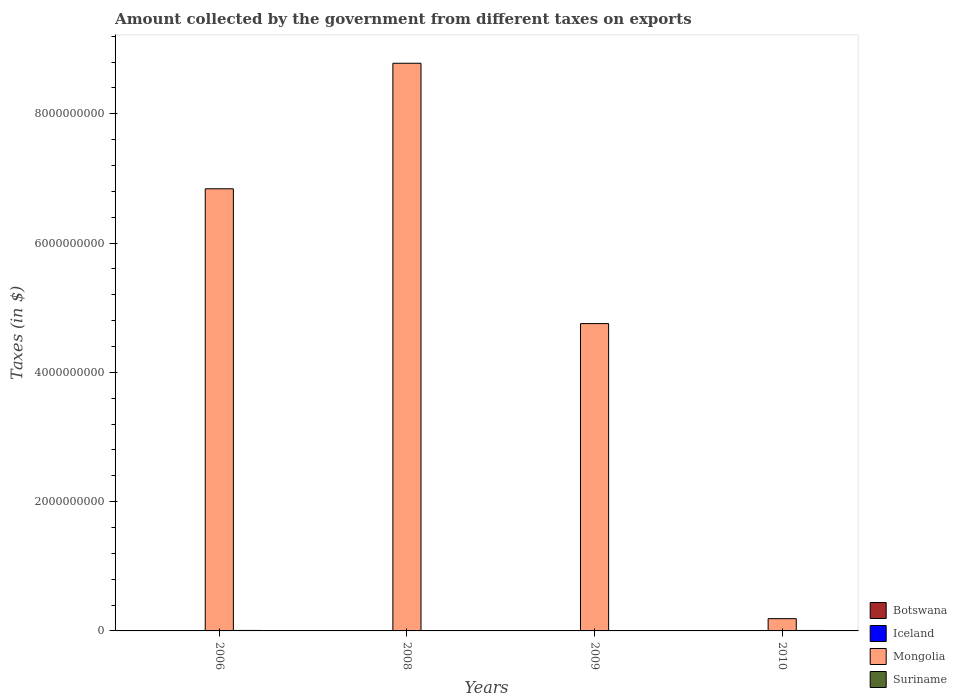How many different coloured bars are there?
Make the answer very short. 4. How many groups of bars are there?
Provide a short and direct response. 4. Are the number of bars per tick equal to the number of legend labels?
Ensure brevity in your answer.  Yes. How many bars are there on the 4th tick from the right?
Offer a terse response. 4. What is the label of the 1st group of bars from the left?
Make the answer very short. 2006. In how many cases, is the number of bars for a given year not equal to the number of legend labels?
Provide a short and direct response. 0. What is the amount collected by the government from taxes on exports in Iceland in 2008?
Provide a succinct answer. 6.26e+06. Across all years, what is the maximum amount collected by the government from taxes on exports in Botswana?
Your response must be concise. 1.69e+06. Across all years, what is the minimum amount collected by the government from taxes on exports in Suriname?
Make the answer very short. 4.27e+06. In which year was the amount collected by the government from taxes on exports in Suriname maximum?
Your response must be concise. 2006. What is the total amount collected by the government from taxes on exports in Botswana in the graph?
Your answer should be very brief. 4.41e+06. What is the difference between the amount collected by the government from taxes on exports in Mongolia in 2006 and that in 2008?
Make the answer very short. -1.94e+09. What is the difference between the amount collected by the government from taxes on exports in Botswana in 2008 and the amount collected by the government from taxes on exports in Mongolia in 2009?
Offer a very short reply. -4.75e+09. What is the average amount collected by the government from taxes on exports in Suriname per year?
Give a very brief answer. 6.07e+06. In the year 2008, what is the difference between the amount collected by the government from taxes on exports in Iceland and amount collected by the government from taxes on exports in Mongolia?
Your answer should be very brief. -8.78e+09. In how many years, is the amount collected by the government from taxes on exports in Iceland greater than 1600000000 $?
Keep it short and to the point. 0. What is the ratio of the amount collected by the government from taxes on exports in Iceland in 2008 to that in 2010?
Your response must be concise. 3.81. Is the amount collected by the government from taxes on exports in Iceland in 2006 less than that in 2008?
Offer a terse response. Yes. What is the difference between the highest and the second highest amount collected by the government from taxes on exports in Mongolia?
Ensure brevity in your answer.  1.94e+09. What is the difference between the highest and the lowest amount collected by the government from taxes on exports in Mongolia?
Keep it short and to the point. 8.59e+09. In how many years, is the amount collected by the government from taxes on exports in Suriname greater than the average amount collected by the government from taxes on exports in Suriname taken over all years?
Give a very brief answer. 2. What does the 4th bar from the right in 2009 represents?
Provide a succinct answer. Botswana. Are all the bars in the graph horizontal?
Your response must be concise. No. What is the difference between two consecutive major ticks on the Y-axis?
Keep it short and to the point. 2.00e+09. Are the values on the major ticks of Y-axis written in scientific E-notation?
Provide a short and direct response. No. Does the graph contain grids?
Your response must be concise. No. Where does the legend appear in the graph?
Your answer should be compact. Bottom right. How are the legend labels stacked?
Provide a short and direct response. Vertical. What is the title of the graph?
Give a very brief answer. Amount collected by the government from different taxes on exports. What is the label or title of the Y-axis?
Keep it short and to the point. Taxes (in $). What is the Taxes (in $) of Iceland in 2006?
Keep it short and to the point. 3.10e+06. What is the Taxes (in $) in Mongolia in 2006?
Give a very brief answer. 6.84e+09. What is the Taxes (in $) in Suriname in 2006?
Give a very brief answer. 7.49e+06. What is the Taxes (in $) in Botswana in 2008?
Offer a terse response. 1.65e+06. What is the Taxes (in $) in Iceland in 2008?
Your answer should be compact. 6.26e+06. What is the Taxes (in $) in Mongolia in 2008?
Provide a succinct answer. 8.78e+09. What is the Taxes (in $) in Suriname in 2008?
Your answer should be compact. 5.36e+06. What is the Taxes (in $) of Botswana in 2009?
Your response must be concise. 7.10e+05. What is the Taxes (in $) in Iceland in 2009?
Offer a very short reply. 5.41e+06. What is the Taxes (in $) of Mongolia in 2009?
Ensure brevity in your answer.  4.75e+09. What is the Taxes (in $) of Suriname in 2009?
Offer a very short reply. 4.27e+06. What is the Taxes (in $) in Botswana in 2010?
Keep it short and to the point. 1.69e+06. What is the Taxes (in $) in Iceland in 2010?
Keep it short and to the point. 1.64e+06. What is the Taxes (in $) in Mongolia in 2010?
Give a very brief answer. 1.90e+08. What is the Taxes (in $) of Suriname in 2010?
Your answer should be compact. 7.16e+06. Across all years, what is the maximum Taxes (in $) in Botswana?
Give a very brief answer. 1.69e+06. Across all years, what is the maximum Taxes (in $) in Iceland?
Ensure brevity in your answer.  6.26e+06. Across all years, what is the maximum Taxes (in $) in Mongolia?
Provide a succinct answer. 8.78e+09. Across all years, what is the maximum Taxes (in $) of Suriname?
Offer a very short reply. 7.49e+06. Across all years, what is the minimum Taxes (in $) of Botswana?
Offer a terse response. 3.60e+05. Across all years, what is the minimum Taxes (in $) in Iceland?
Offer a very short reply. 1.64e+06. Across all years, what is the minimum Taxes (in $) of Mongolia?
Your answer should be compact. 1.90e+08. Across all years, what is the minimum Taxes (in $) of Suriname?
Your answer should be very brief. 4.27e+06. What is the total Taxes (in $) of Botswana in the graph?
Keep it short and to the point. 4.41e+06. What is the total Taxes (in $) of Iceland in the graph?
Provide a succinct answer. 1.64e+07. What is the total Taxes (in $) in Mongolia in the graph?
Provide a succinct answer. 2.06e+1. What is the total Taxes (in $) in Suriname in the graph?
Provide a succinct answer. 2.43e+07. What is the difference between the Taxes (in $) in Botswana in 2006 and that in 2008?
Give a very brief answer. -1.29e+06. What is the difference between the Taxes (in $) of Iceland in 2006 and that in 2008?
Offer a terse response. -3.16e+06. What is the difference between the Taxes (in $) of Mongolia in 2006 and that in 2008?
Your response must be concise. -1.94e+09. What is the difference between the Taxes (in $) in Suriname in 2006 and that in 2008?
Give a very brief answer. 2.14e+06. What is the difference between the Taxes (in $) in Botswana in 2006 and that in 2009?
Provide a succinct answer. -3.50e+05. What is the difference between the Taxes (in $) of Iceland in 2006 and that in 2009?
Your response must be concise. -2.31e+06. What is the difference between the Taxes (in $) in Mongolia in 2006 and that in 2009?
Provide a succinct answer. 2.09e+09. What is the difference between the Taxes (in $) in Suriname in 2006 and that in 2009?
Offer a terse response. 3.22e+06. What is the difference between the Taxes (in $) in Botswana in 2006 and that in 2010?
Offer a very short reply. -1.33e+06. What is the difference between the Taxes (in $) of Iceland in 2006 and that in 2010?
Make the answer very short. 1.46e+06. What is the difference between the Taxes (in $) in Mongolia in 2006 and that in 2010?
Provide a succinct answer. 6.65e+09. What is the difference between the Taxes (in $) of Suriname in 2006 and that in 2010?
Offer a very short reply. 3.33e+05. What is the difference between the Taxes (in $) of Botswana in 2008 and that in 2009?
Keep it short and to the point. 9.40e+05. What is the difference between the Taxes (in $) in Iceland in 2008 and that in 2009?
Provide a short and direct response. 8.44e+05. What is the difference between the Taxes (in $) in Mongolia in 2008 and that in 2009?
Provide a succinct answer. 4.03e+09. What is the difference between the Taxes (in $) of Suriname in 2008 and that in 2009?
Your response must be concise. 1.08e+06. What is the difference between the Taxes (in $) in Iceland in 2008 and that in 2010?
Give a very brief answer. 4.61e+06. What is the difference between the Taxes (in $) in Mongolia in 2008 and that in 2010?
Ensure brevity in your answer.  8.59e+09. What is the difference between the Taxes (in $) in Suriname in 2008 and that in 2010?
Give a very brief answer. -1.81e+06. What is the difference between the Taxes (in $) in Botswana in 2009 and that in 2010?
Ensure brevity in your answer.  -9.80e+05. What is the difference between the Taxes (in $) of Iceland in 2009 and that in 2010?
Make the answer very short. 3.77e+06. What is the difference between the Taxes (in $) in Mongolia in 2009 and that in 2010?
Your answer should be compact. 4.57e+09. What is the difference between the Taxes (in $) in Suriname in 2009 and that in 2010?
Your answer should be very brief. -2.89e+06. What is the difference between the Taxes (in $) in Botswana in 2006 and the Taxes (in $) in Iceland in 2008?
Keep it short and to the point. -5.90e+06. What is the difference between the Taxes (in $) in Botswana in 2006 and the Taxes (in $) in Mongolia in 2008?
Keep it short and to the point. -8.78e+09. What is the difference between the Taxes (in $) of Botswana in 2006 and the Taxes (in $) of Suriname in 2008?
Offer a terse response. -5.00e+06. What is the difference between the Taxes (in $) in Iceland in 2006 and the Taxes (in $) in Mongolia in 2008?
Provide a succinct answer. -8.78e+09. What is the difference between the Taxes (in $) in Iceland in 2006 and the Taxes (in $) in Suriname in 2008?
Keep it short and to the point. -2.26e+06. What is the difference between the Taxes (in $) in Mongolia in 2006 and the Taxes (in $) in Suriname in 2008?
Give a very brief answer. 6.83e+09. What is the difference between the Taxes (in $) of Botswana in 2006 and the Taxes (in $) of Iceland in 2009?
Ensure brevity in your answer.  -5.05e+06. What is the difference between the Taxes (in $) in Botswana in 2006 and the Taxes (in $) in Mongolia in 2009?
Offer a very short reply. -4.75e+09. What is the difference between the Taxes (in $) in Botswana in 2006 and the Taxes (in $) in Suriname in 2009?
Your answer should be compact. -3.91e+06. What is the difference between the Taxes (in $) in Iceland in 2006 and the Taxes (in $) in Mongolia in 2009?
Give a very brief answer. -4.75e+09. What is the difference between the Taxes (in $) of Iceland in 2006 and the Taxes (in $) of Suriname in 2009?
Provide a succinct answer. -1.17e+06. What is the difference between the Taxes (in $) of Mongolia in 2006 and the Taxes (in $) of Suriname in 2009?
Provide a succinct answer. 6.84e+09. What is the difference between the Taxes (in $) in Botswana in 2006 and the Taxes (in $) in Iceland in 2010?
Give a very brief answer. -1.28e+06. What is the difference between the Taxes (in $) in Botswana in 2006 and the Taxes (in $) in Mongolia in 2010?
Offer a terse response. -1.89e+08. What is the difference between the Taxes (in $) in Botswana in 2006 and the Taxes (in $) in Suriname in 2010?
Make the answer very short. -6.80e+06. What is the difference between the Taxes (in $) in Iceland in 2006 and the Taxes (in $) in Mongolia in 2010?
Ensure brevity in your answer.  -1.87e+08. What is the difference between the Taxes (in $) in Iceland in 2006 and the Taxes (in $) in Suriname in 2010?
Keep it short and to the point. -4.06e+06. What is the difference between the Taxes (in $) of Mongolia in 2006 and the Taxes (in $) of Suriname in 2010?
Provide a succinct answer. 6.83e+09. What is the difference between the Taxes (in $) of Botswana in 2008 and the Taxes (in $) of Iceland in 2009?
Make the answer very short. -3.76e+06. What is the difference between the Taxes (in $) of Botswana in 2008 and the Taxes (in $) of Mongolia in 2009?
Ensure brevity in your answer.  -4.75e+09. What is the difference between the Taxes (in $) of Botswana in 2008 and the Taxes (in $) of Suriname in 2009?
Make the answer very short. -2.62e+06. What is the difference between the Taxes (in $) in Iceland in 2008 and the Taxes (in $) in Mongolia in 2009?
Offer a very short reply. -4.75e+09. What is the difference between the Taxes (in $) in Iceland in 2008 and the Taxes (in $) in Suriname in 2009?
Offer a terse response. 1.98e+06. What is the difference between the Taxes (in $) in Mongolia in 2008 and the Taxes (in $) in Suriname in 2009?
Your response must be concise. 8.78e+09. What is the difference between the Taxes (in $) of Botswana in 2008 and the Taxes (in $) of Iceland in 2010?
Your answer should be very brief. 8550. What is the difference between the Taxes (in $) in Botswana in 2008 and the Taxes (in $) in Mongolia in 2010?
Offer a very short reply. -1.88e+08. What is the difference between the Taxes (in $) of Botswana in 2008 and the Taxes (in $) of Suriname in 2010?
Provide a short and direct response. -5.51e+06. What is the difference between the Taxes (in $) of Iceland in 2008 and the Taxes (in $) of Mongolia in 2010?
Offer a terse response. -1.84e+08. What is the difference between the Taxes (in $) in Iceland in 2008 and the Taxes (in $) in Suriname in 2010?
Your answer should be very brief. -9.07e+05. What is the difference between the Taxes (in $) in Mongolia in 2008 and the Taxes (in $) in Suriname in 2010?
Your answer should be very brief. 8.78e+09. What is the difference between the Taxes (in $) in Botswana in 2009 and the Taxes (in $) in Iceland in 2010?
Ensure brevity in your answer.  -9.31e+05. What is the difference between the Taxes (in $) in Botswana in 2009 and the Taxes (in $) in Mongolia in 2010?
Provide a short and direct response. -1.89e+08. What is the difference between the Taxes (in $) of Botswana in 2009 and the Taxes (in $) of Suriname in 2010?
Your answer should be very brief. -6.45e+06. What is the difference between the Taxes (in $) in Iceland in 2009 and the Taxes (in $) in Mongolia in 2010?
Give a very brief answer. -1.84e+08. What is the difference between the Taxes (in $) in Iceland in 2009 and the Taxes (in $) in Suriname in 2010?
Your response must be concise. -1.75e+06. What is the difference between the Taxes (in $) of Mongolia in 2009 and the Taxes (in $) of Suriname in 2010?
Your response must be concise. 4.75e+09. What is the average Taxes (in $) of Botswana per year?
Offer a terse response. 1.10e+06. What is the average Taxes (in $) of Iceland per year?
Your answer should be very brief. 4.10e+06. What is the average Taxes (in $) of Mongolia per year?
Ensure brevity in your answer.  5.14e+09. What is the average Taxes (in $) of Suriname per year?
Provide a succinct answer. 6.07e+06. In the year 2006, what is the difference between the Taxes (in $) of Botswana and Taxes (in $) of Iceland?
Offer a terse response. -2.74e+06. In the year 2006, what is the difference between the Taxes (in $) of Botswana and Taxes (in $) of Mongolia?
Offer a very short reply. -6.84e+09. In the year 2006, what is the difference between the Taxes (in $) of Botswana and Taxes (in $) of Suriname?
Your answer should be compact. -7.13e+06. In the year 2006, what is the difference between the Taxes (in $) of Iceland and Taxes (in $) of Mongolia?
Your response must be concise. -6.84e+09. In the year 2006, what is the difference between the Taxes (in $) of Iceland and Taxes (in $) of Suriname?
Your response must be concise. -4.39e+06. In the year 2006, what is the difference between the Taxes (in $) in Mongolia and Taxes (in $) in Suriname?
Provide a succinct answer. 6.83e+09. In the year 2008, what is the difference between the Taxes (in $) of Botswana and Taxes (in $) of Iceland?
Your answer should be compact. -4.61e+06. In the year 2008, what is the difference between the Taxes (in $) in Botswana and Taxes (in $) in Mongolia?
Give a very brief answer. -8.78e+09. In the year 2008, what is the difference between the Taxes (in $) in Botswana and Taxes (in $) in Suriname?
Offer a terse response. -3.71e+06. In the year 2008, what is the difference between the Taxes (in $) of Iceland and Taxes (in $) of Mongolia?
Your response must be concise. -8.78e+09. In the year 2008, what is the difference between the Taxes (in $) in Iceland and Taxes (in $) in Suriname?
Give a very brief answer. 9.00e+05. In the year 2008, what is the difference between the Taxes (in $) of Mongolia and Taxes (in $) of Suriname?
Give a very brief answer. 8.78e+09. In the year 2009, what is the difference between the Taxes (in $) of Botswana and Taxes (in $) of Iceland?
Offer a very short reply. -4.70e+06. In the year 2009, what is the difference between the Taxes (in $) in Botswana and Taxes (in $) in Mongolia?
Your answer should be compact. -4.75e+09. In the year 2009, what is the difference between the Taxes (in $) of Botswana and Taxes (in $) of Suriname?
Your answer should be very brief. -3.56e+06. In the year 2009, what is the difference between the Taxes (in $) in Iceland and Taxes (in $) in Mongolia?
Provide a short and direct response. -4.75e+09. In the year 2009, what is the difference between the Taxes (in $) of Iceland and Taxes (in $) of Suriname?
Provide a short and direct response. 1.14e+06. In the year 2009, what is the difference between the Taxes (in $) of Mongolia and Taxes (in $) of Suriname?
Ensure brevity in your answer.  4.75e+09. In the year 2010, what is the difference between the Taxes (in $) of Botswana and Taxes (in $) of Iceland?
Provide a succinct answer. 4.86e+04. In the year 2010, what is the difference between the Taxes (in $) of Botswana and Taxes (in $) of Mongolia?
Keep it short and to the point. -1.88e+08. In the year 2010, what is the difference between the Taxes (in $) in Botswana and Taxes (in $) in Suriname?
Provide a short and direct response. -5.47e+06. In the year 2010, what is the difference between the Taxes (in $) of Iceland and Taxes (in $) of Mongolia?
Give a very brief answer. -1.88e+08. In the year 2010, what is the difference between the Taxes (in $) of Iceland and Taxes (in $) of Suriname?
Make the answer very short. -5.52e+06. In the year 2010, what is the difference between the Taxes (in $) in Mongolia and Taxes (in $) in Suriname?
Your answer should be very brief. 1.83e+08. What is the ratio of the Taxes (in $) in Botswana in 2006 to that in 2008?
Your answer should be compact. 0.22. What is the ratio of the Taxes (in $) in Iceland in 2006 to that in 2008?
Provide a short and direct response. 0.5. What is the ratio of the Taxes (in $) of Mongolia in 2006 to that in 2008?
Your answer should be very brief. 0.78. What is the ratio of the Taxes (in $) in Suriname in 2006 to that in 2008?
Your answer should be very brief. 1.4. What is the ratio of the Taxes (in $) in Botswana in 2006 to that in 2009?
Your answer should be very brief. 0.51. What is the ratio of the Taxes (in $) in Iceland in 2006 to that in 2009?
Provide a succinct answer. 0.57. What is the ratio of the Taxes (in $) in Mongolia in 2006 to that in 2009?
Keep it short and to the point. 1.44. What is the ratio of the Taxes (in $) of Suriname in 2006 to that in 2009?
Provide a short and direct response. 1.75. What is the ratio of the Taxes (in $) of Botswana in 2006 to that in 2010?
Ensure brevity in your answer.  0.21. What is the ratio of the Taxes (in $) in Iceland in 2006 to that in 2010?
Give a very brief answer. 1.89. What is the ratio of the Taxes (in $) of Mongolia in 2006 to that in 2010?
Give a very brief answer. 36.04. What is the ratio of the Taxes (in $) in Suriname in 2006 to that in 2010?
Give a very brief answer. 1.05. What is the ratio of the Taxes (in $) in Botswana in 2008 to that in 2009?
Keep it short and to the point. 2.32. What is the ratio of the Taxes (in $) in Iceland in 2008 to that in 2009?
Your answer should be compact. 1.16. What is the ratio of the Taxes (in $) in Mongolia in 2008 to that in 2009?
Provide a short and direct response. 1.85. What is the ratio of the Taxes (in $) in Suriname in 2008 to that in 2009?
Your response must be concise. 1.25. What is the ratio of the Taxes (in $) in Botswana in 2008 to that in 2010?
Offer a terse response. 0.98. What is the ratio of the Taxes (in $) of Iceland in 2008 to that in 2010?
Ensure brevity in your answer.  3.81. What is the ratio of the Taxes (in $) in Mongolia in 2008 to that in 2010?
Your answer should be compact. 46.27. What is the ratio of the Taxes (in $) in Suriname in 2008 to that in 2010?
Provide a short and direct response. 0.75. What is the ratio of the Taxes (in $) in Botswana in 2009 to that in 2010?
Offer a terse response. 0.42. What is the ratio of the Taxes (in $) in Iceland in 2009 to that in 2010?
Offer a very short reply. 3.3. What is the ratio of the Taxes (in $) of Mongolia in 2009 to that in 2010?
Make the answer very short. 25.05. What is the ratio of the Taxes (in $) of Suriname in 2009 to that in 2010?
Make the answer very short. 0.6. What is the difference between the highest and the second highest Taxes (in $) of Iceland?
Make the answer very short. 8.44e+05. What is the difference between the highest and the second highest Taxes (in $) of Mongolia?
Provide a short and direct response. 1.94e+09. What is the difference between the highest and the second highest Taxes (in $) of Suriname?
Provide a short and direct response. 3.33e+05. What is the difference between the highest and the lowest Taxes (in $) in Botswana?
Your answer should be compact. 1.33e+06. What is the difference between the highest and the lowest Taxes (in $) of Iceland?
Your answer should be very brief. 4.61e+06. What is the difference between the highest and the lowest Taxes (in $) of Mongolia?
Your answer should be very brief. 8.59e+09. What is the difference between the highest and the lowest Taxes (in $) of Suriname?
Give a very brief answer. 3.22e+06. 